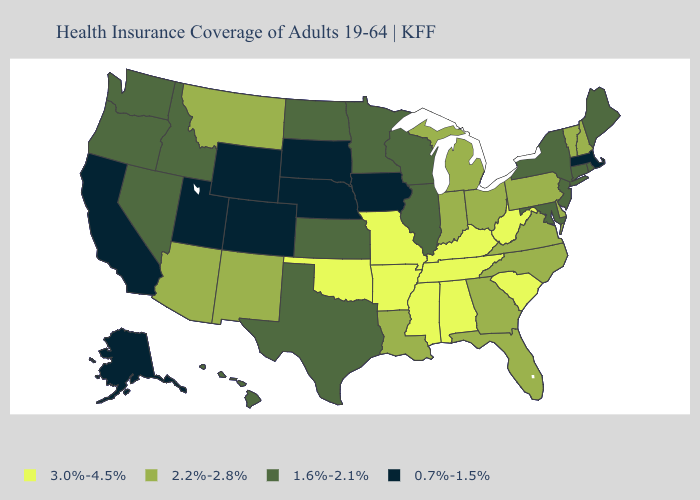What is the value of Kansas?
Concise answer only. 1.6%-2.1%. Name the states that have a value in the range 2.2%-2.8%?
Be succinct. Arizona, Delaware, Florida, Georgia, Indiana, Louisiana, Michigan, Montana, New Hampshire, New Mexico, North Carolina, Ohio, Pennsylvania, Vermont, Virginia. What is the value of North Dakota?
Short answer required. 1.6%-2.1%. What is the value of Florida?
Give a very brief answer. 2.2%-2.8%. Name the states that have a value in the range 1.6%-2.1%?
Give a very brief answer. Connecticut, Hawaii, Idaho, Illinois, Kansas, Maine, Maryland, Minnesota, Nevada, New Jersey, New York, North Dakota, Oregon, Rhode Island, Texas, Washington, Wisconsin. Which states have the highest value in the USA?
Write a very short answer. Alabama, Arkansas, Kentucky, Mississippi, Missouri, Oklahoma, South Carolina, Tennessee, West Virginia. How many symbols are there in the legend?
Answer briefly. 4. Among the states that border New York , which have the lowest value?
Write a very short answer. Massachusetts. Among the states that border Wisconsin , does Michigan have the highest value?
Concise answer only. Yes. Name the states that have a value in the range 1.6%-2.1%?
Be succinct. Connecticut, Hawaii, Idaho, Illinois, Kansas, Maine, Maryland, Minnesota, Nevada, New Jersey, New York, North Dakota, Oregon, Rhode Island, Texas, Washington, Wisconsin. Does Maine have the highest value in the Northeast?
Keep it brief. No. Name the states that have a value in the range 0.7%-1.5%?
Write a very short answer. Alaska, California, Colorado, Iowa, Massachusetts, Nebraska, South Dakota, Utah, Wyoming. Which states hav the highest value in the South?
Quick response, please. Alabama, Arkansas, Kentucky, Mississippi, Oklahoma, South Carolina, Tennessee, West Virginia. What is the highest value in the USA?
Quick response, please. 3.0%-4.5%. Does North Carolina have the same value as Tennessee?
Write a very short answer. No. 